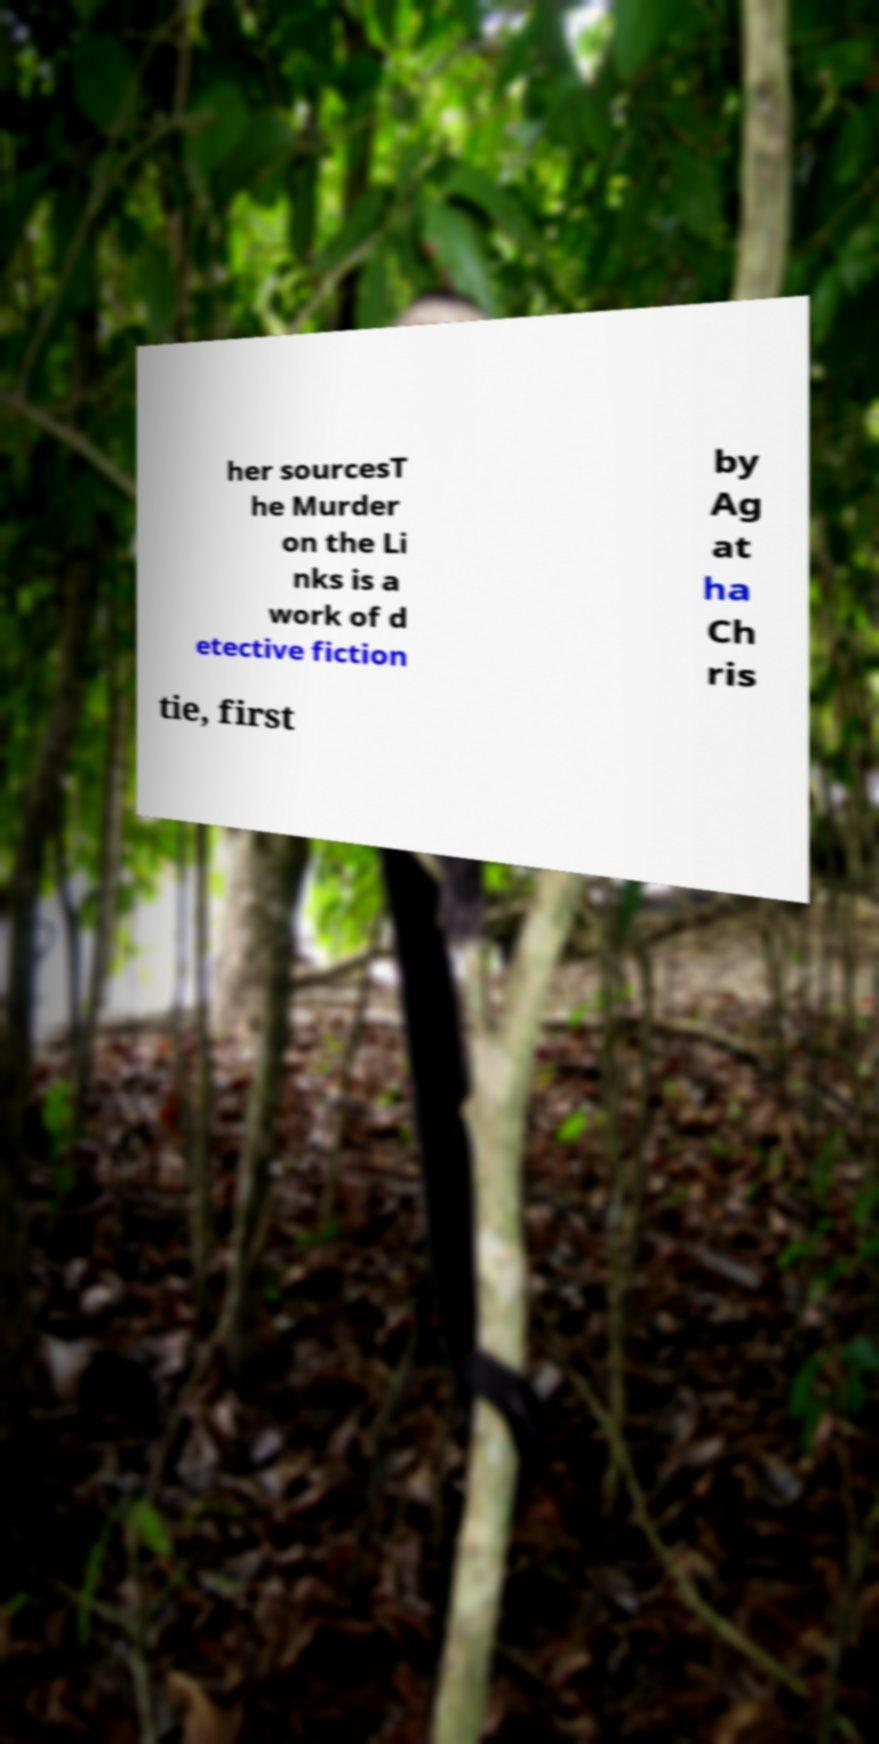What messages or text are displayed in this image? I need them in a readable, typed format. her sourcesT he Murder on the Li nks is a work of d etective fiction by Ag at ha Ch ris tie, first 